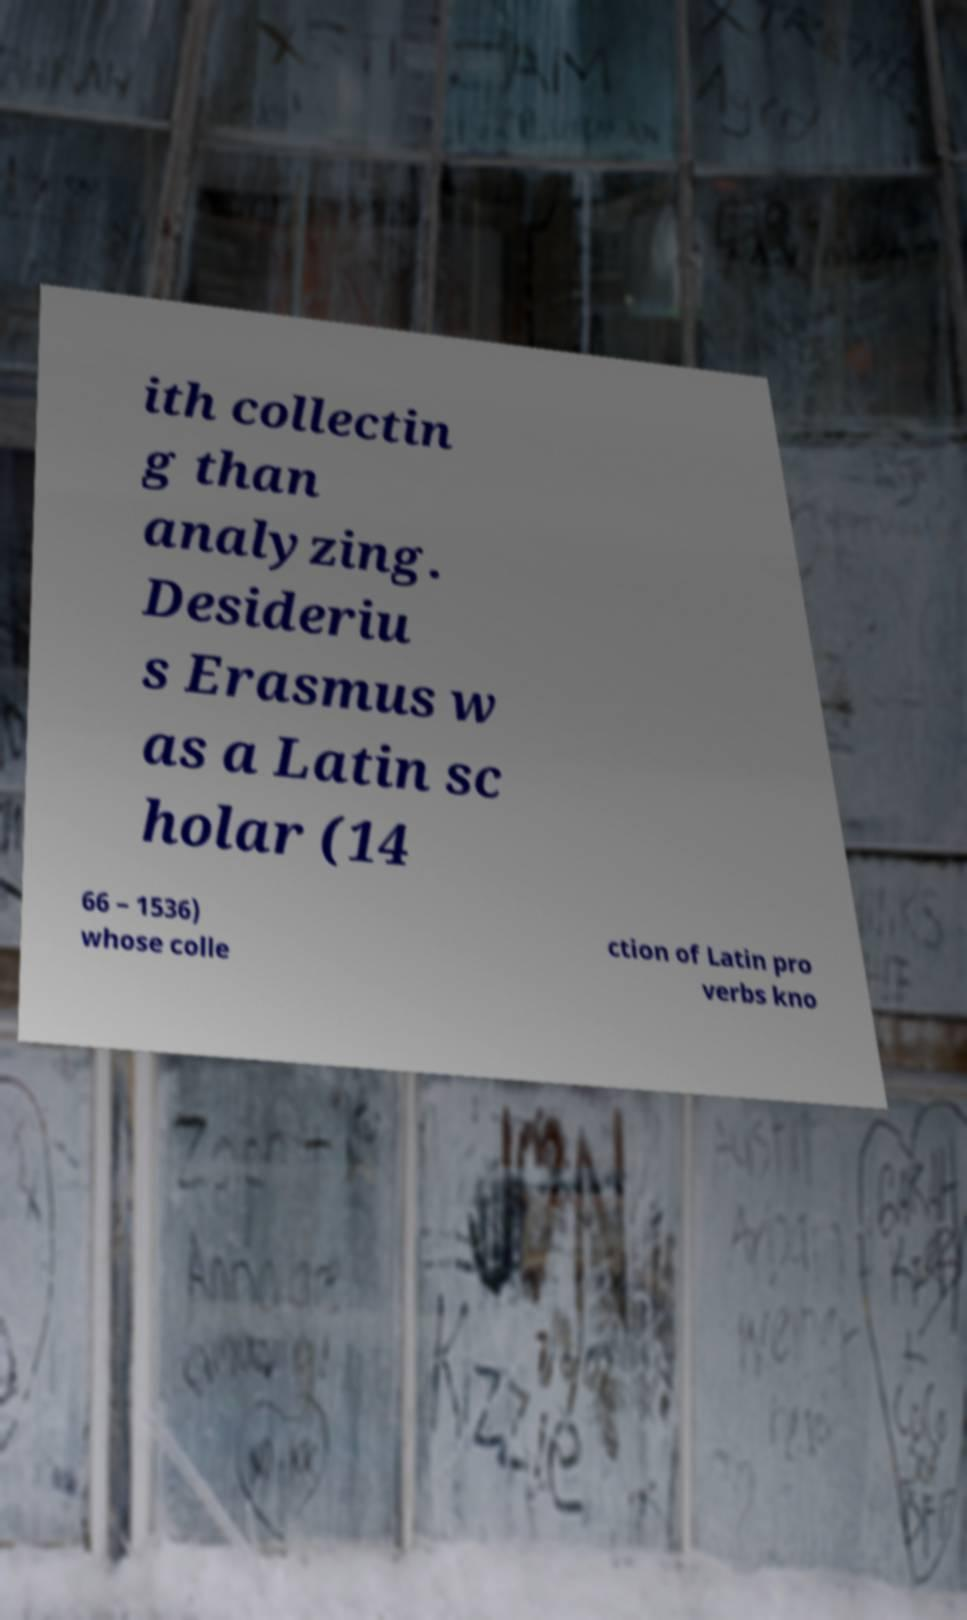For documentation purposes, I need the text within this image transcribed. Could you provide that? ith collectin g than analyzing. Desideriu s Erasmus w as a Latin sc holar (14 66 – 1536) whose colle ction of Latin pro verbs kno 